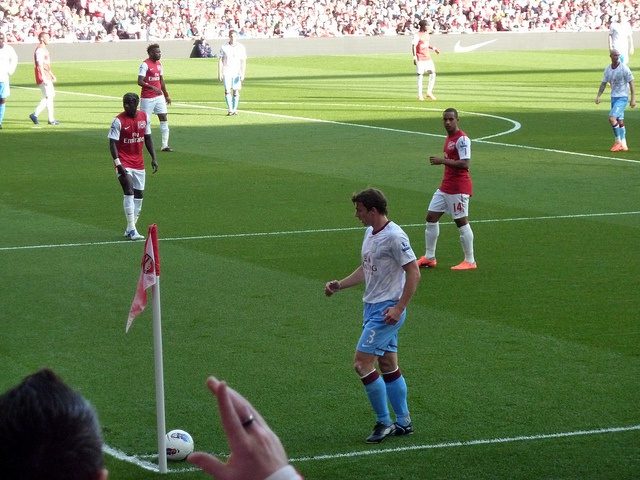Describe the objects in this image and their specific colors. I can see people in lightpink, white, darkgray, and gray tones, people in lightpink, black, gray, maroon, and darkgray tones, people in lightpink, gray, black, and blue tones, people in lightpink, maroon, darkgray, gray, and black tones, and people in lightpink, black, maroon, gray, and darkgray tones in this image. 